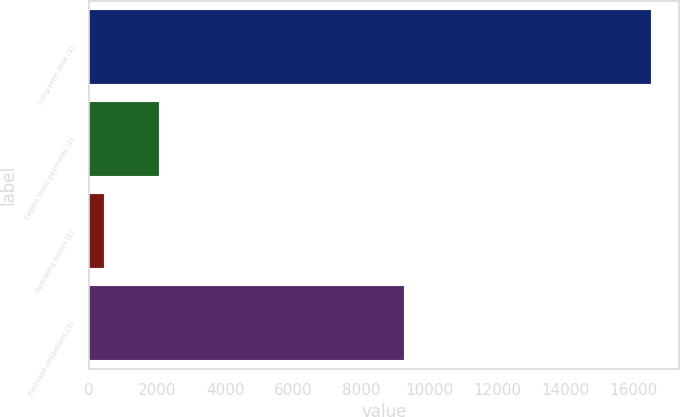Convert chart. <chart><loc_0><loc_0><loc_500><loc_500><bar_chart><fcel>Long-term debt (1)<fcel>Capital lease payments (2)<fcel>Operating leases (2)<fcel>Purchase obligations (3)<nl><fcel>16516<fcel>2054.8<fcel>448<fcel>9250<nl></chart> 